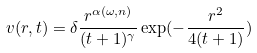Convert formula to latex. <formula><loc_0><loc_0><loc_500><loc_500>v ( r , t ) = \delta \frac { r ^ { \alpha ( \omega , n ) } } { ( t + 1 ) ^ { \gamma } } \exp ( - \frac { r ^ { 2 } } { 4 ( t + 1 ) } )</formula> 